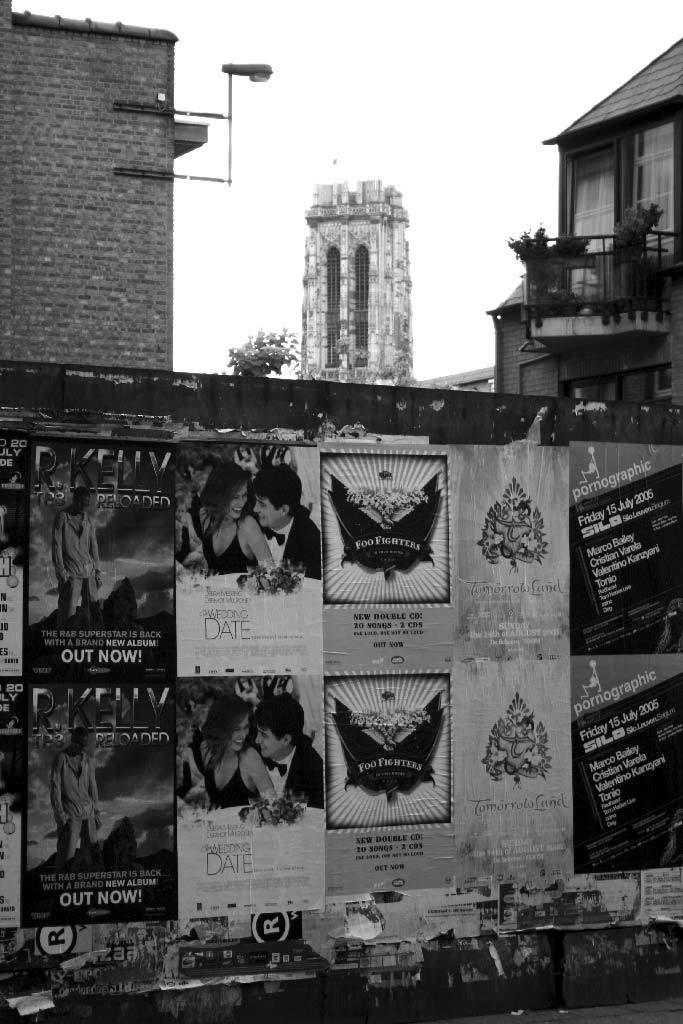What is on the wall in the image? There are posters on the wall in the image. What type of structures can be seen in the image? There are buildings visible in the image. Where is the balcony located in the image? The balcony is in the image. What type of vegetation is present in the image? There is a plant in the image. What is the source of illumination in the image? There is a light in the image. What type of pathway is visible in the image? There is a footpath in the image. What is the color of the sky in the image? The sky is white in the image. Can you see the tail of the animal in the image? There is no animal with a tail present in the image. What type of lift is visible in the image? There is no lift present in the image. 